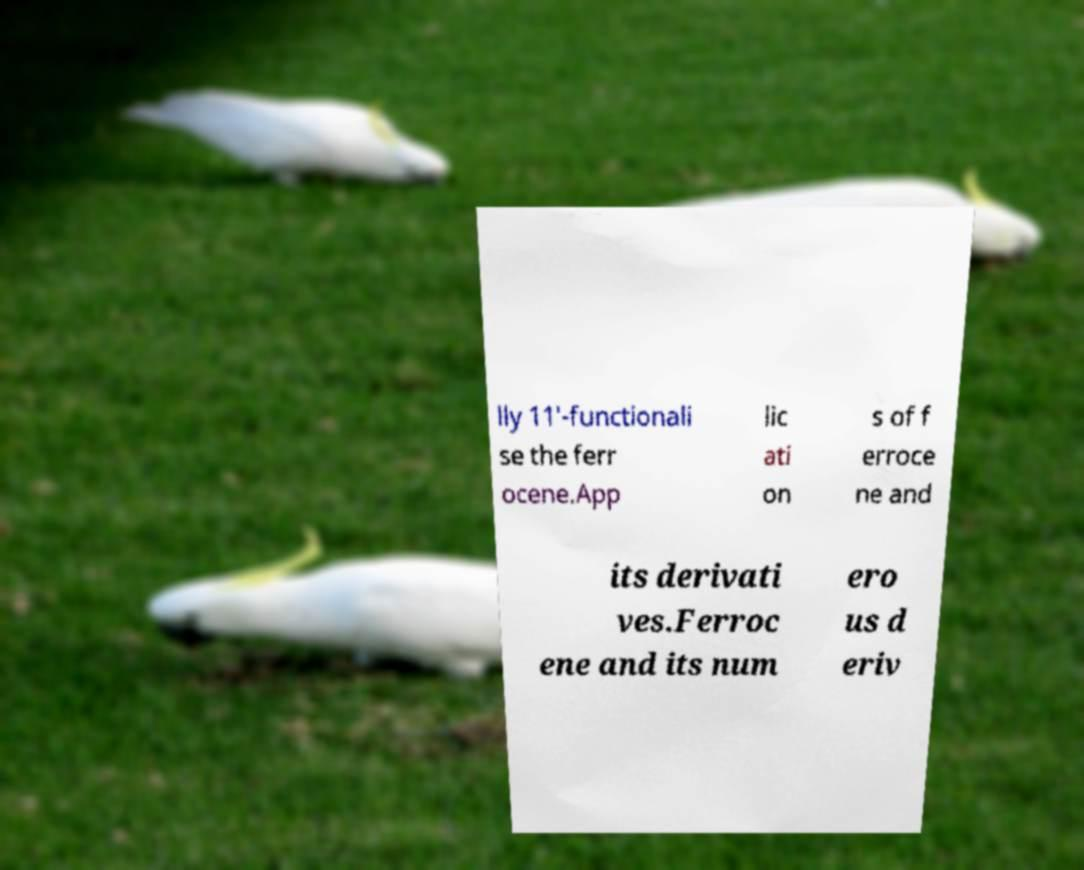I need the written content from this picture converted into text. Can you do that? lly 11′-functionali se the ferr ocene.App lic ati on s of f erroce ne and its derivati ves.Ferroc ene and its num ero us d eriv 